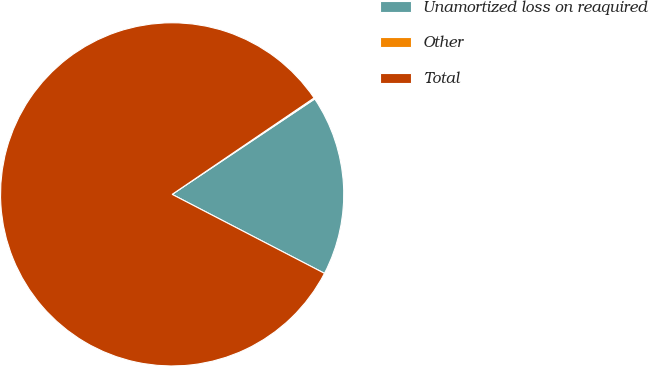<chart> <loc_0><loc_0><loc_500><loc_500><pie_chart><fcel>Unamortized loss on reaquired<fcel>Other<fcel>Total<nl><fcel>17.0%<fcel>0.11%<fcel>82.89%<nl></chart> 